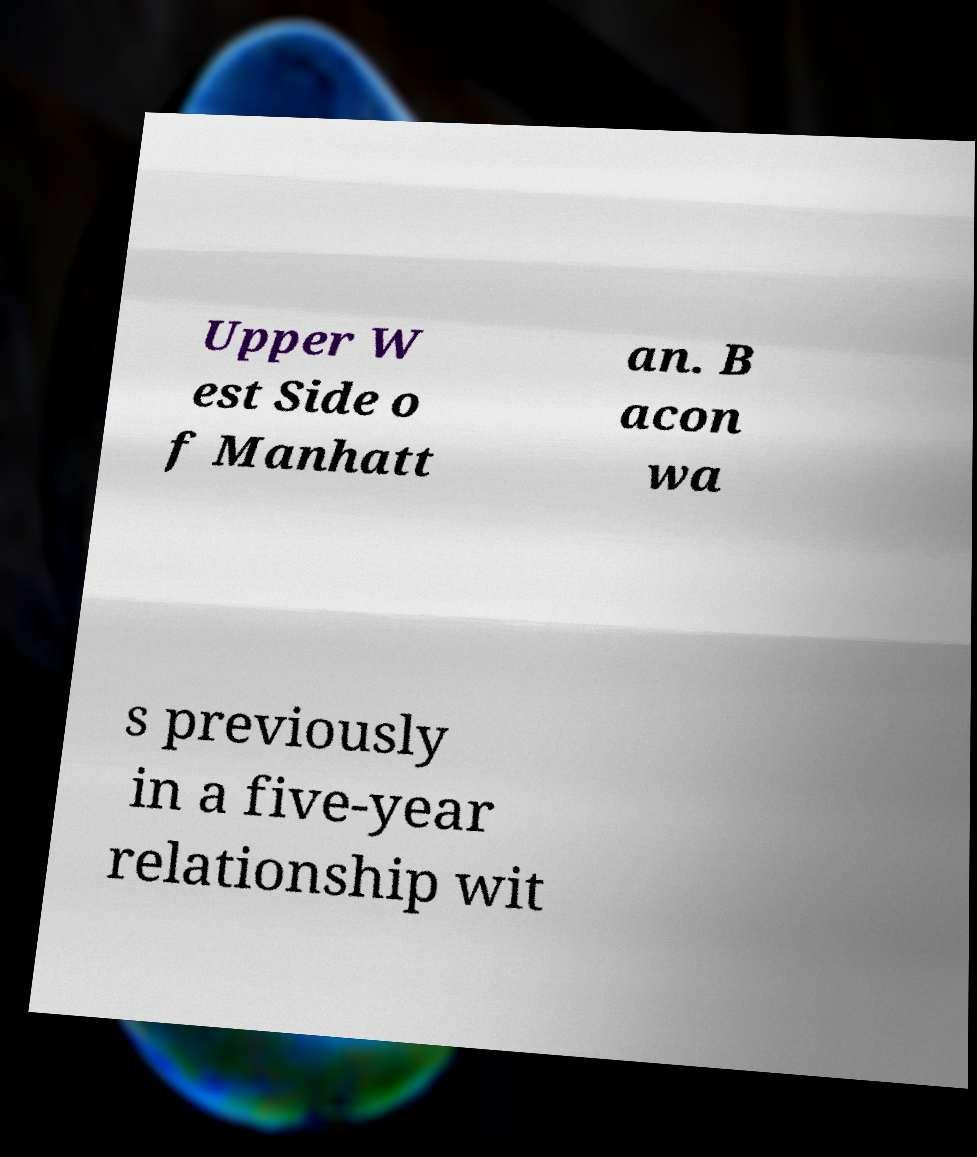I need the written content from this picture converted into text. Can you do that? Upper W est Side o f Manhatt an. B acon wa s previously in a five-year relationship wit 